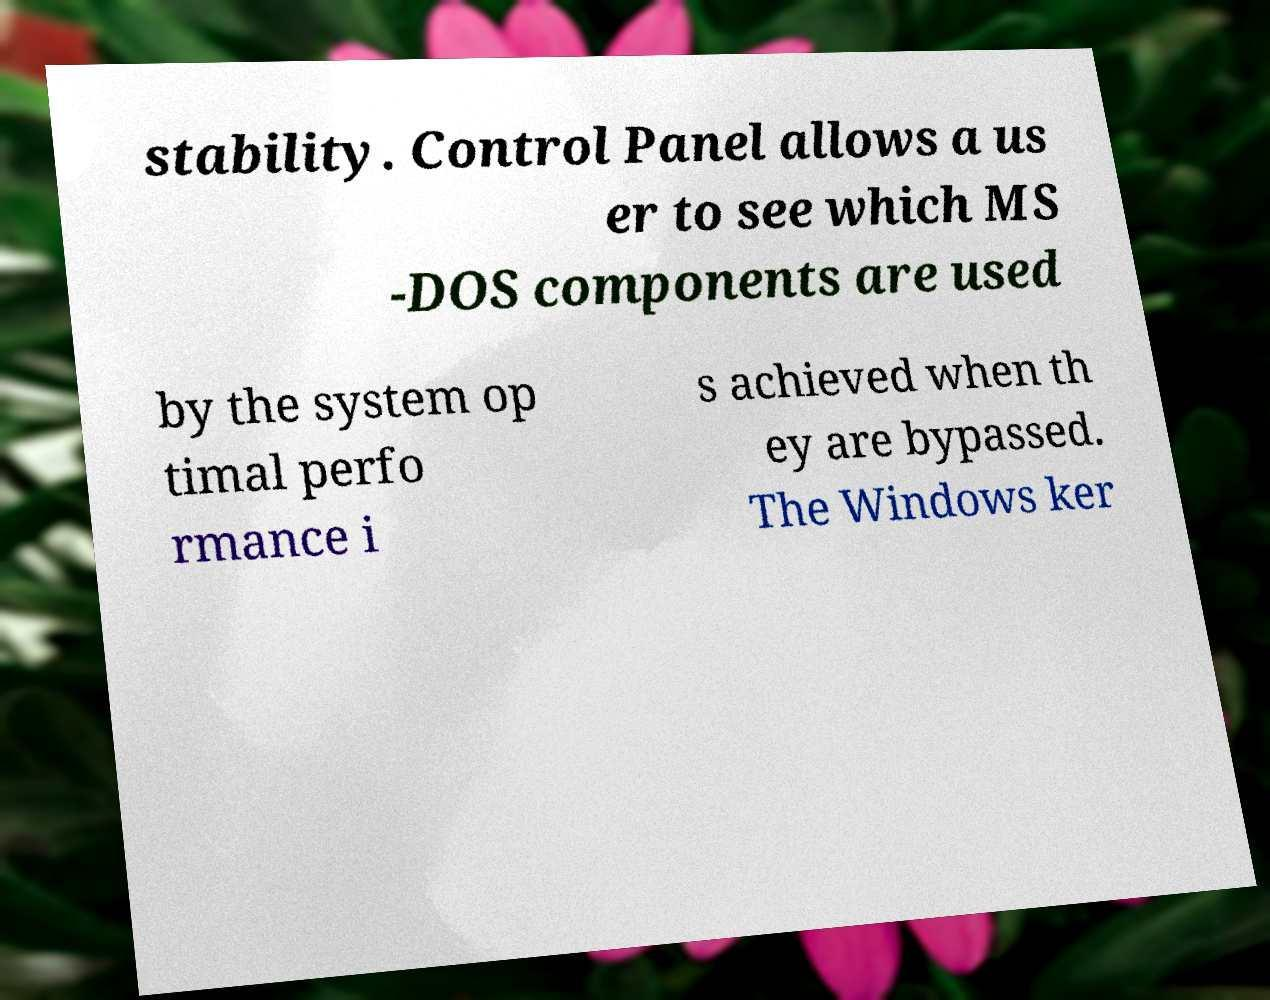For documentation purposes, I need the text within this image transcribed. Could you provide that? stability. Control Panel allows a us er to see which MS -DOS components are used by the system op timal perfo rmance i s achieved when th ey are bypassed. The Windows ker 